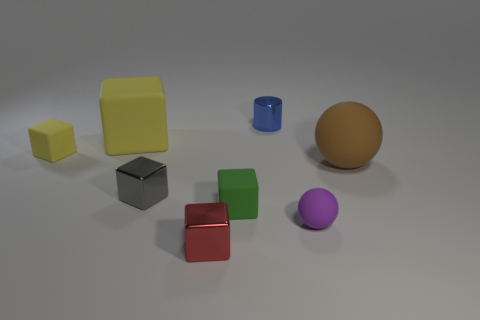What number of objects are either blocks that are behind the tiny green matte cube or large green metallic cylinders?
Provide a succinct answer. 3. There is a brown object that is made of the same material as the green object; what size is it?
Give a very brief answer. Large. Are there more things that are right of the red thing than big blue shiny cylinders?
Offer a very short reply. Yes. There is a blue metal object; does it have the same shape as the big matte thing that is right of the tiny matte sphere?
Offer a terse response. No. How many small things are things or green cubes?
Give a very brief answer. 6. What size is the other matte block that is the same color as the big block?
Give a very brief answer. Small. The big object to the left of the rubber sphere that is in front of the large brown sphere is what color?
Offer a terse response. Yellow. Does the gray cube have the same material as the sphere in front of the brown object?
Provide a succinct answer. No. There is a gray thing that is in front of the tiny yellow object; what is its material?
Keep it short and to the point. Metal. Are there an equal number of yellow rubber blocks that are in front of the large ball and purple rubber blocks?
Offer a terse response. Yes. 